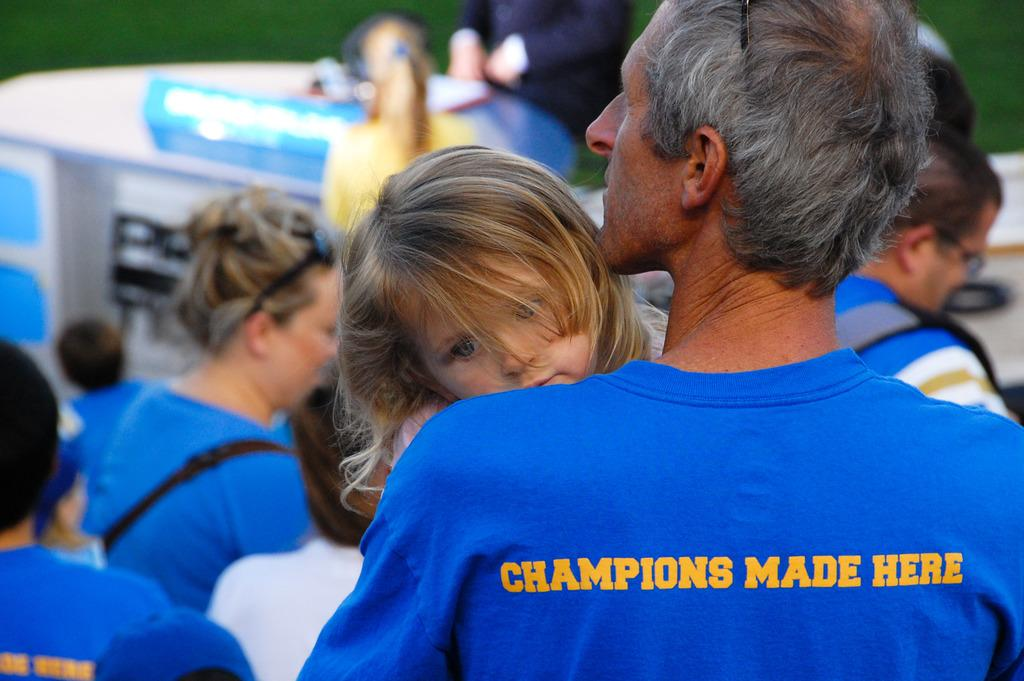What is the person in the image wearing? The person is wearing a blue T-shirt in the image. What is the person doing with the little girl? The person is holding a little girl in the image. How many people can be seen in the image? There are many people standing in the image. Can you tell me what the monkey is doing in the image? There is no monkey present in the image. Is the person talking to the little girl in the image? The image does not show or indicate any conversation between the person and the little girl. 